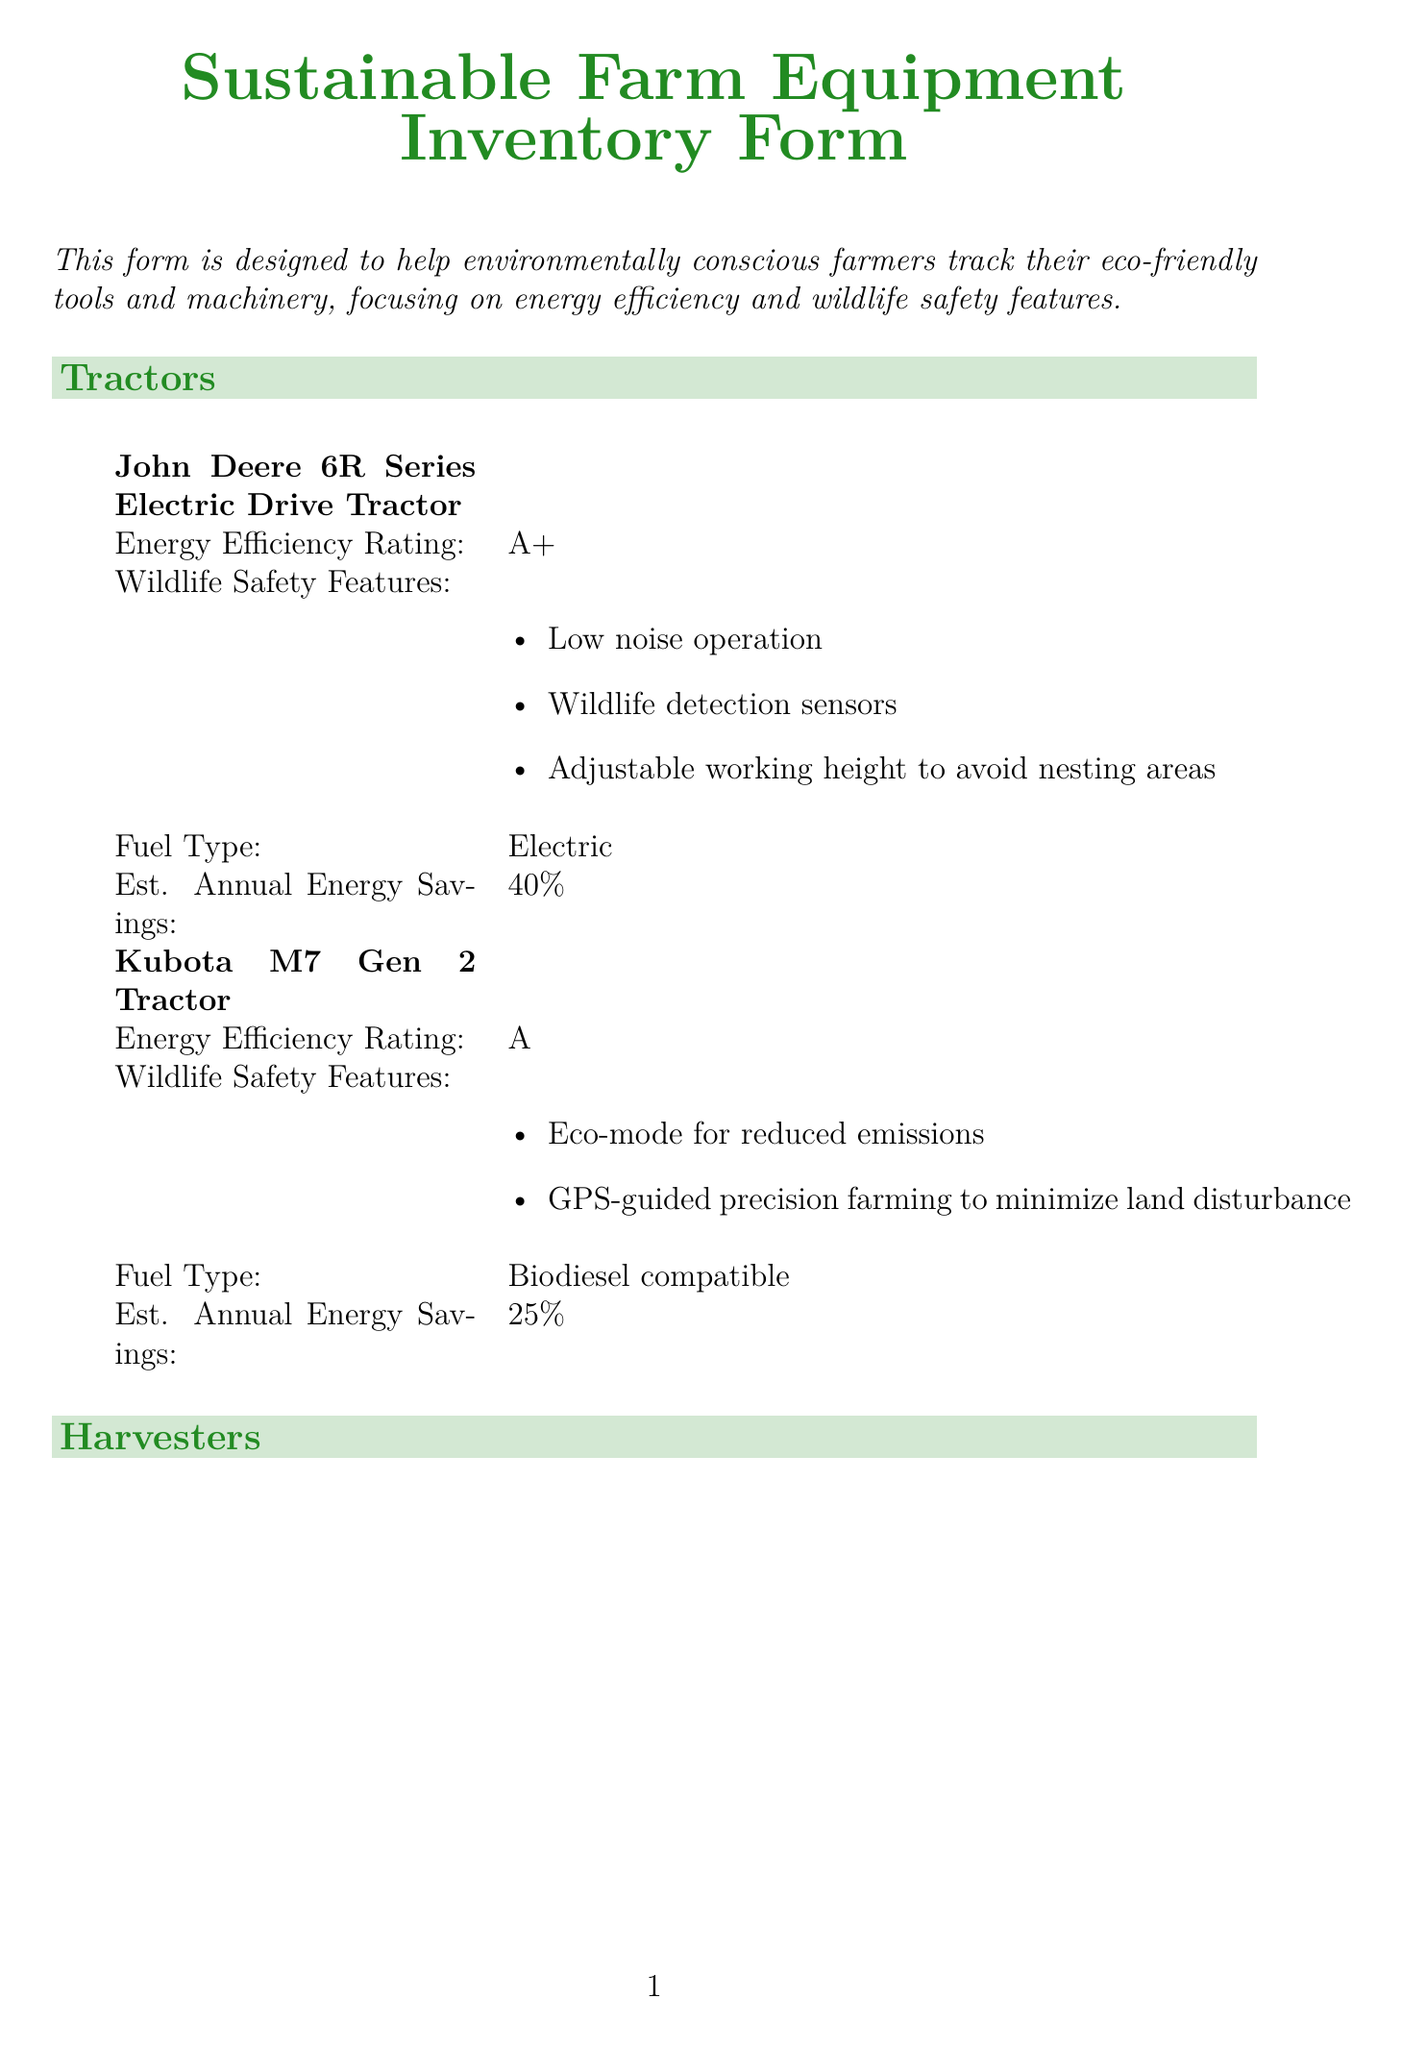what is the energy efficiency rating of the John Deere 6R Series Electric Drive Tractor? The document specifies this rating as A+.
Answer: A+ what feature helps detect wildlife for the John Deere 6R Series Electric Drive Tractor? The document lists wildlife detection sensors as one of its safety features.
Answer: Wildlife detection sensors how much can the Lindsay Zimmatic Center Pivot save in annual water usage? The estimated water savings for this irrigation system is stated as 35%.
Answer: 35% what is the power source of the Netafim Subsurface Drip Irrigation System? The form indicates that this system is powered by grid electricity with smart metering.
Answer: Grid electricity with smart metering which planting equipment is compatible with low-power tractors? The Vaderstad Tempo L Planter is specifically mentioned as compatible with low-power tractors.
Answer: Vaderstad Tempo L Planter which pest control equipment has an energy efficiency rating of A++? The Ecorobotix AVO Autonomous Robot Weeder falls into this category according to the document.
Answer: Ecorobotix AVO Autonomous Robot Weeder what is one wildlife safety feature of the Claas Lexion 8900 Terra Trac? The document notes night vision cameras for nocturnal wildlife detection as a safety feature.
Answer: Night vision cameras for nocturnal wildlife detection how much is the estimated annual herbicide reduction for the Ecorobotix AVO? It is highlighted in the form as 95%.
Answer: 95% 